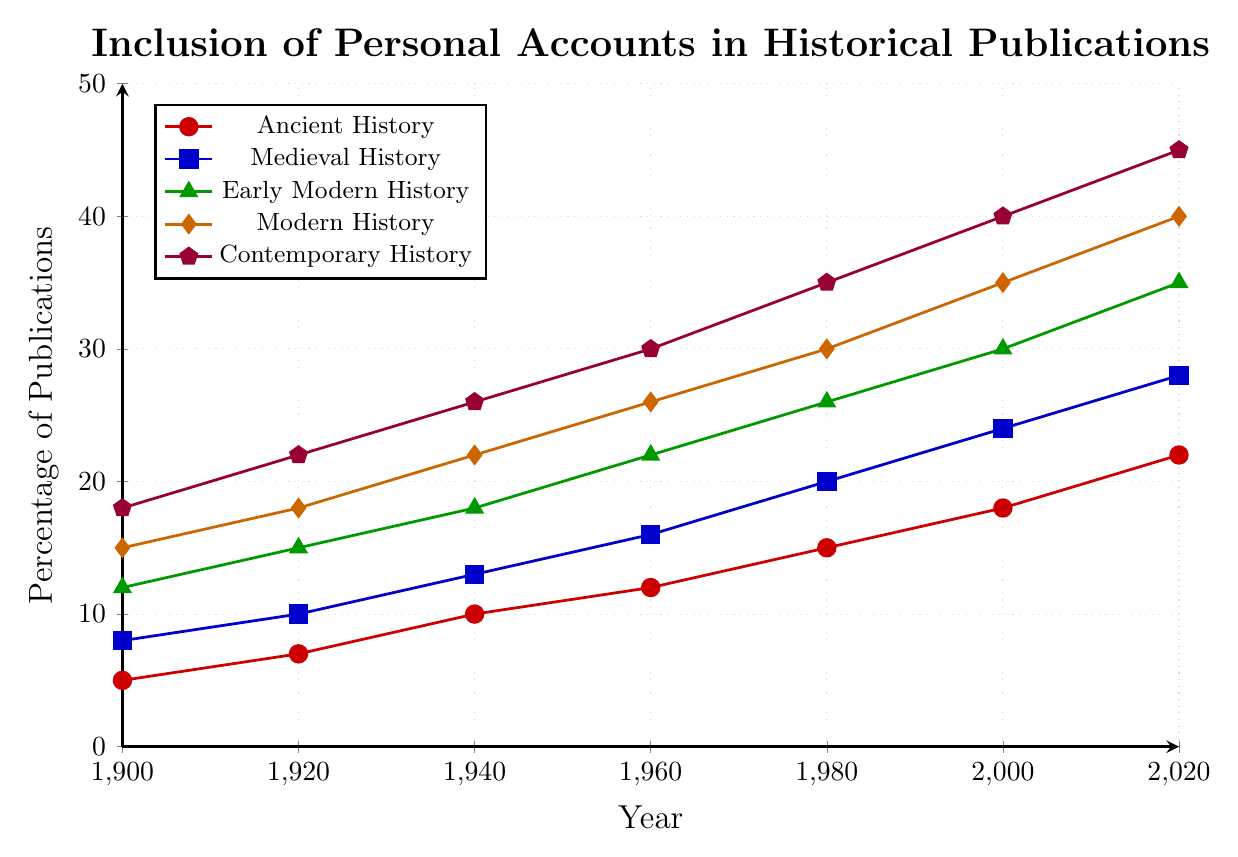What is the trend for publications related to Medieval History from 1900 to 2020? The line for Medieval History shows a consistent upward trend from 1900 (8%) to 2020 (28%) in the figure. This indicates an increasing inclusion of personal letters and diaries in publications over time.
Answer: Upward trend Which historical period covered the highest percentage of publications by 2020? The figure shows that the line representing Contemporary History reaches the highest point (45%) in 2020, compared to other periods.
Answer: Contemporary History In which year did Ancient History see a noticeable increase in inclusion compared to the previous period? Ancient History shows a more noticeable increase between 1940 (10%) and 1960 (12%), compared to smaller increases in earlier periods.
Answer: Between 1940 and 1960 How does the increase in the inclusion of personal accounts for Early Modern History compare between 1960 and 1980? For Early Modern History, the percentage increased from 22% in 1960 to 26% in 1980, a difference of 4 percentage points.
Answer: 4 percentage points Calculate the average percentage of publications for Modern History from 1900 to 2020. To find the average: add the values for Modern History (15% + 18% + 22% + 26% + 30% + 35% + 40%) = 186, then divide by the number of data points (7). So, 186/7 ≈ 26.57%.
Answer: 26.57% Which historical period had the least inclusion of personal letters and diaries in 1920, and what was the percentage? The figure shows that Ancient History had the least inclusion in 1920, with a percentage of 7%.
Answer: Ancient History, 7% What's the median percentage of publications for Contemporary History from 1900 to 2020? The percentages for Contemporary History are: 18%, 22%, 26%, 30%, 35%, 40%, 45%. To find the median, we arrange these values in ascending order and identify the middle number, which is the fourth value (30%).
Answer: 30% Between 1900 and 2020, which period saw the highest increase in inclusion percentage, and by how much? Contemporary History saw the highest increase from 18% in 1900 to 45% in 2020. The difference is 45% - 18% = 27 percentage points.
Answer: Contemporary History, 27 percentage points Compare the percentages between Medieval History and Modern History in 1960. In 1960, Medieval History had 16%, while Modern History had 26%, making Modern History 10 percentage points higher.
Answer: Modern History, 10 percentage points higher 